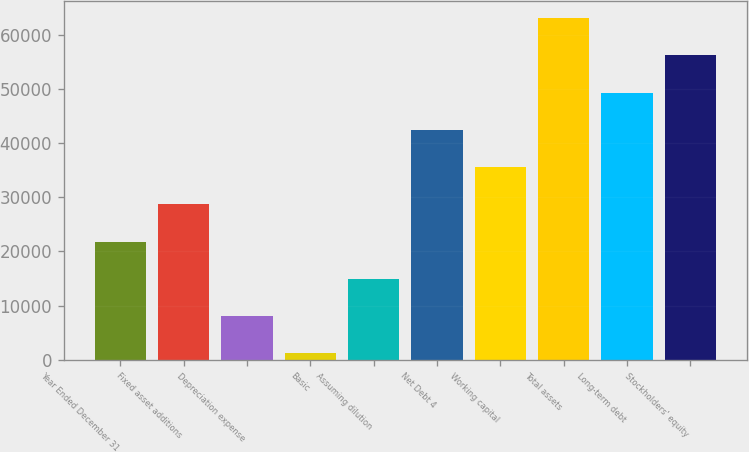Convert chart to OTSL. <chart><loc_0><loc_0><loc_500><loc_500><bar_chart><fcel>Year Ended December 31<fcel>Fixed asset additions<fcel>Depreciation expense<fcel>Basic<fcel>Assuming dilution<fcel>Net Debt 4<fcel>Working capital<fcel>Total assets<fcel>Long-term debt<fcel>Stockholders' equity<nl><fcel>21827.4<fcel>28709.2<fcel>8063.8<fcel>1182<fcel>14945.6<fcel>42472.8<fcel>35591<fcel>63118.2<fcel>49354.6<fcel>56236.4<nl></chart> 